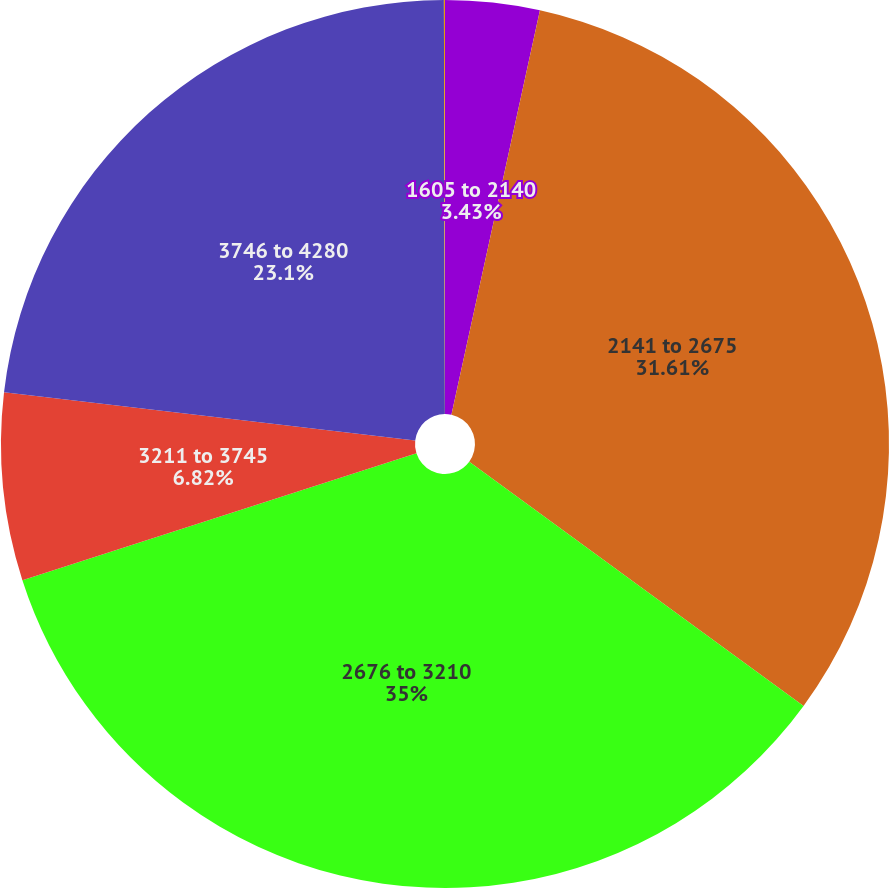Convert chart. <chart><loc_0><loc_0><loc_500><loc_500><pie_chart><fcel>1605 to 2140<fcel>2141 to 2675<fcel>2676 to 3210<fcel>3211 to 3745<fcel>3746 to 4280<fcel>4281 to 4815<nl><fcel>3.43%<fcel>31.61%<fcel>35.0%<fcel>6.82%<fcel>23.1%<fcel>0.04%<nl></chart> 